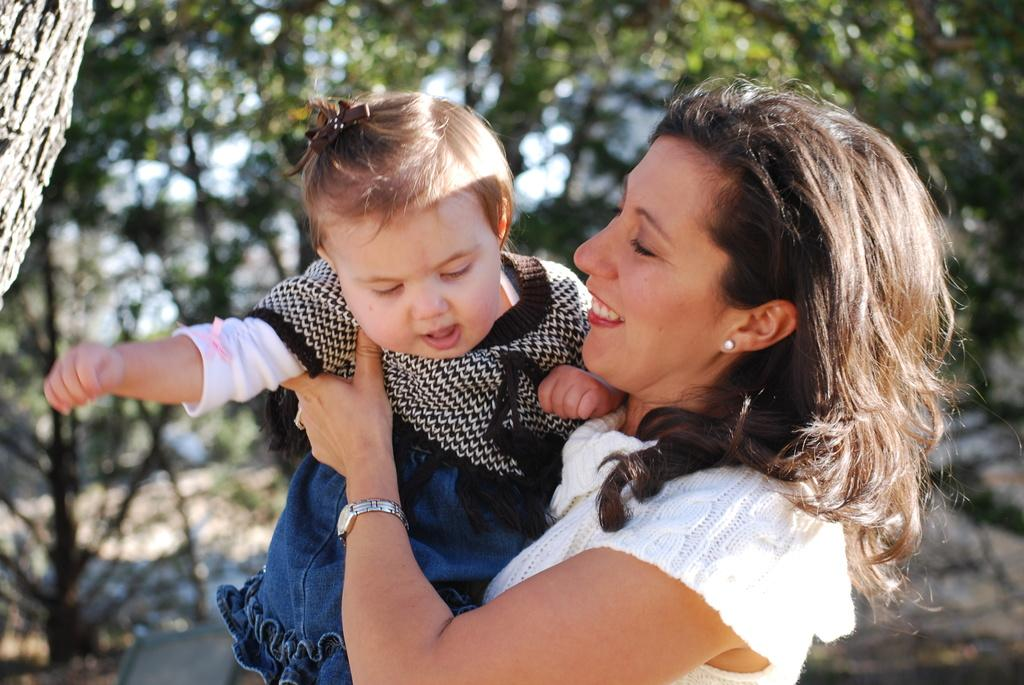What is the woman doing in the image? The woman is holding a baby in the image. What is the woman wearing in the image? The woman is wearing a white dress in the image. What is the woman's facial expression in the image? The woman is smiling in the image. What can be seen in the background of the image? There are trees in the background of the image. What accessory is the woman wearing on her hand? The woman is wearing a watch on her hand in the image. What type of shoes is the woman wearing in the image? The provided facts do not mention shoes, so we cannot determine the type of shoes the woman is wearing in the image. 